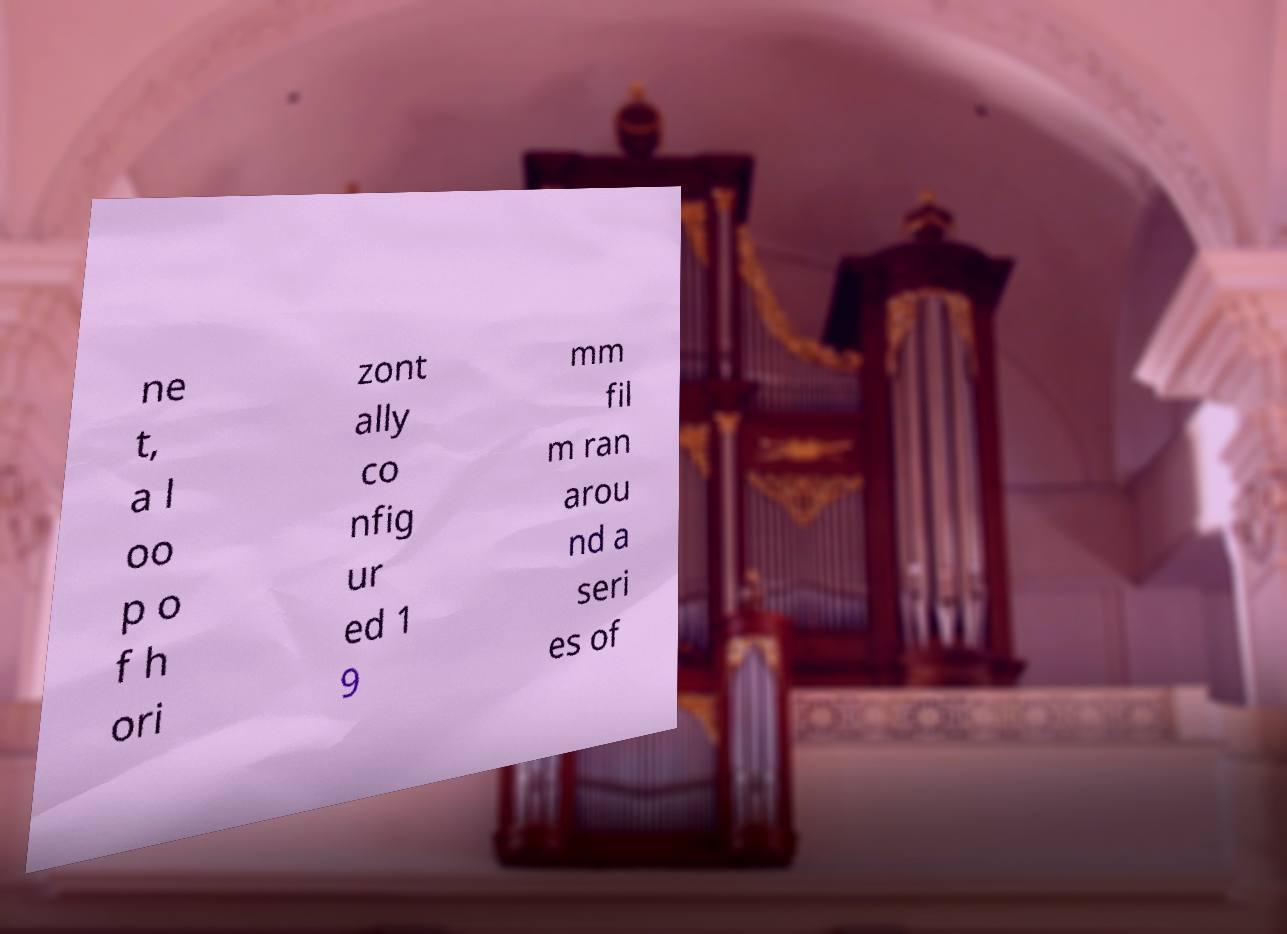There's text embedded in this image that I need extracted. Can you transcribe it verbatim? ne t, a l oo p o f h ori zont ally co nfig ur ed 1 9 mm fil m ran arou nd a seri es of 